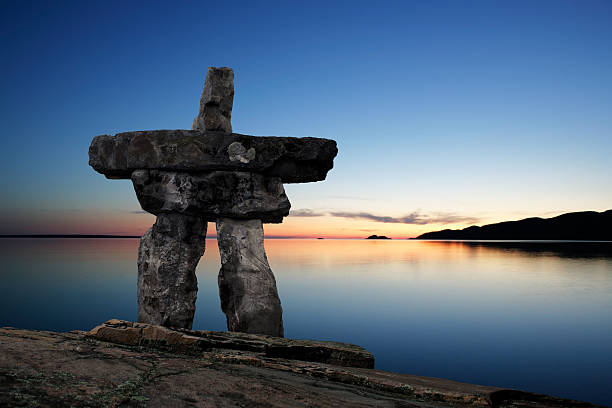If you could have a conversation with the sun setting in this image, what would it say? The sun, glowing in its descent, might whisper tales of the day just passed, sharing the warm moments it illuminated and the shadows it gently cast aside. It would tell stories of the lands it has kissed with its rays, the vast seas it has watched over, and the myriad life forms it has nurtured with its light. As it sinks below the horizon, it might express a serene promise to return, bringing with it a new dawn filled with hope and endless possibilities. In the quiet moments of twilight, the sun would bid a gentle farewell, its glow a reminder of the constant cycle of endings that birth new beginnings. Describe the Inukshuk's view of the world, standing there day and night. The Inukshuk, steadfast and enduring, holds a unique perspective of the world around it. From its vantage point on the rocky shore, it witnesses the ceaseless dance of the elements—the ebb and flow of tides, the ever-changing sky, and the shifting seasons. During the day, the Inukshuk watches as life unfolds in harmony with nature. Birds soar and fish leap, while the sun traces its arc across the sky. As night falls, the Inukshuk stands sentinel under the stars, bathed in the silver light of the moon. It feels the cool breeze of the night, hears the soothing whispers of the waves, and observes the tranquil beauty of the world asleep. Through rain and snow, sunshine and storms, the Inukshuk remains a silent witness to the timeless beauty and ever-changing rhythms of nature. Imagine the Inukshuk coming to life. What would it explore first and why? If the Inukshuk were to come to life, its first exploration would likely be the expanse of the Arctic wilderness that surrounds it. Driven by curiosity and a deep connection to its origins, it would trace the paths of ancient Inuit hunters, learning the secrets of the land and the stories hidden within the icy terrain. With each step, the Inukshuk would interact with the wildlife, feeling the heartbeat of the Arctic ecosystem. It would seek out other Inukshuks, forming connections and sharing the silent wisdom they’ve gathered while standing, frozen in time. This journey would be both a discovery of its heritage and an adventure into the vibrant, living tapestry of its world. 